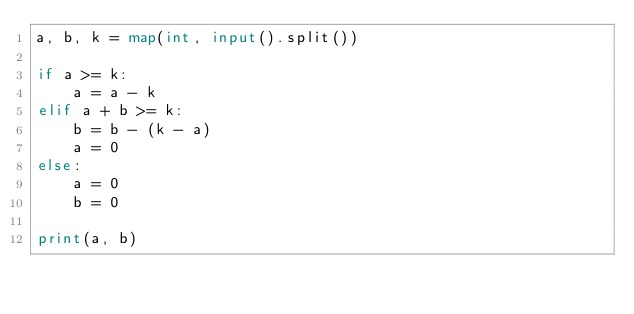<code> <loc_0><loc_0><loc_500><loc_500><_Python_>a, b, k = map(int, input().split())

if a >= k:
	a = a - k
elif a + b >= k:
	b = b - (k - a)
	a = 0
else:
	a = 0
	b = 0
		
print(a, b)</code> 